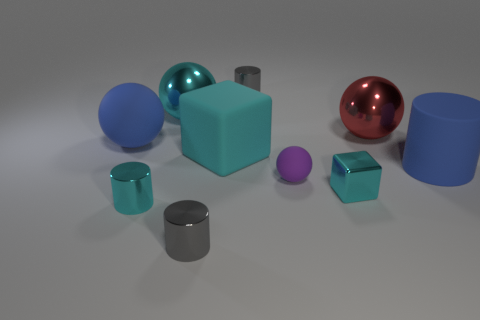Can you describe the lighting and shadows in the scene? The scene is lit from above, creating soft shadows directly underneath each object. The lighting is diffused, with no harsh shadows, suggesting an overcast or ambient light source. 